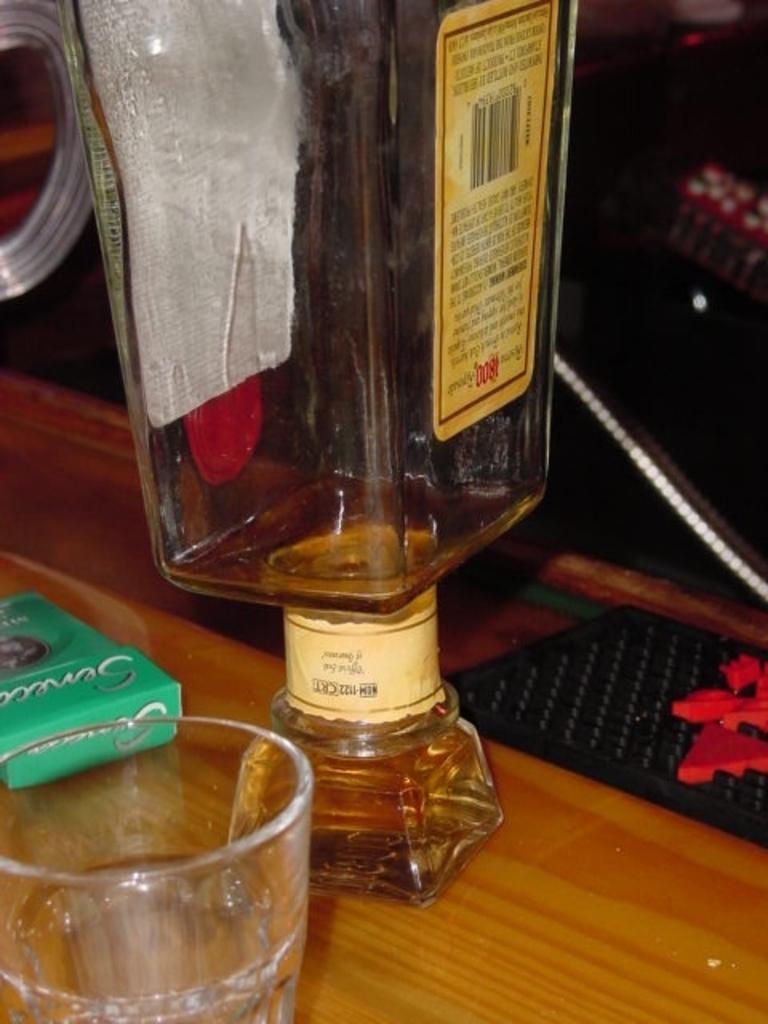What is one of the main objects in the image? There is a bottle in the image. What other object is present in the image? There is a glass in the image. Can you describe the surface where the objects are placed? There are other objects on a wooden plank. What can be seen in the background of the image? There are objects in the background of the image. How would you describe the lighting in the image? The background appears to be dark. What type of argument is taking place between the objects in the image? There is no argument taking place between the objects in the image, as they are inanimate objects. Can you hear any sound coming from the objects in the image? There is no sound coming from the objects in the image, as they are still images. 